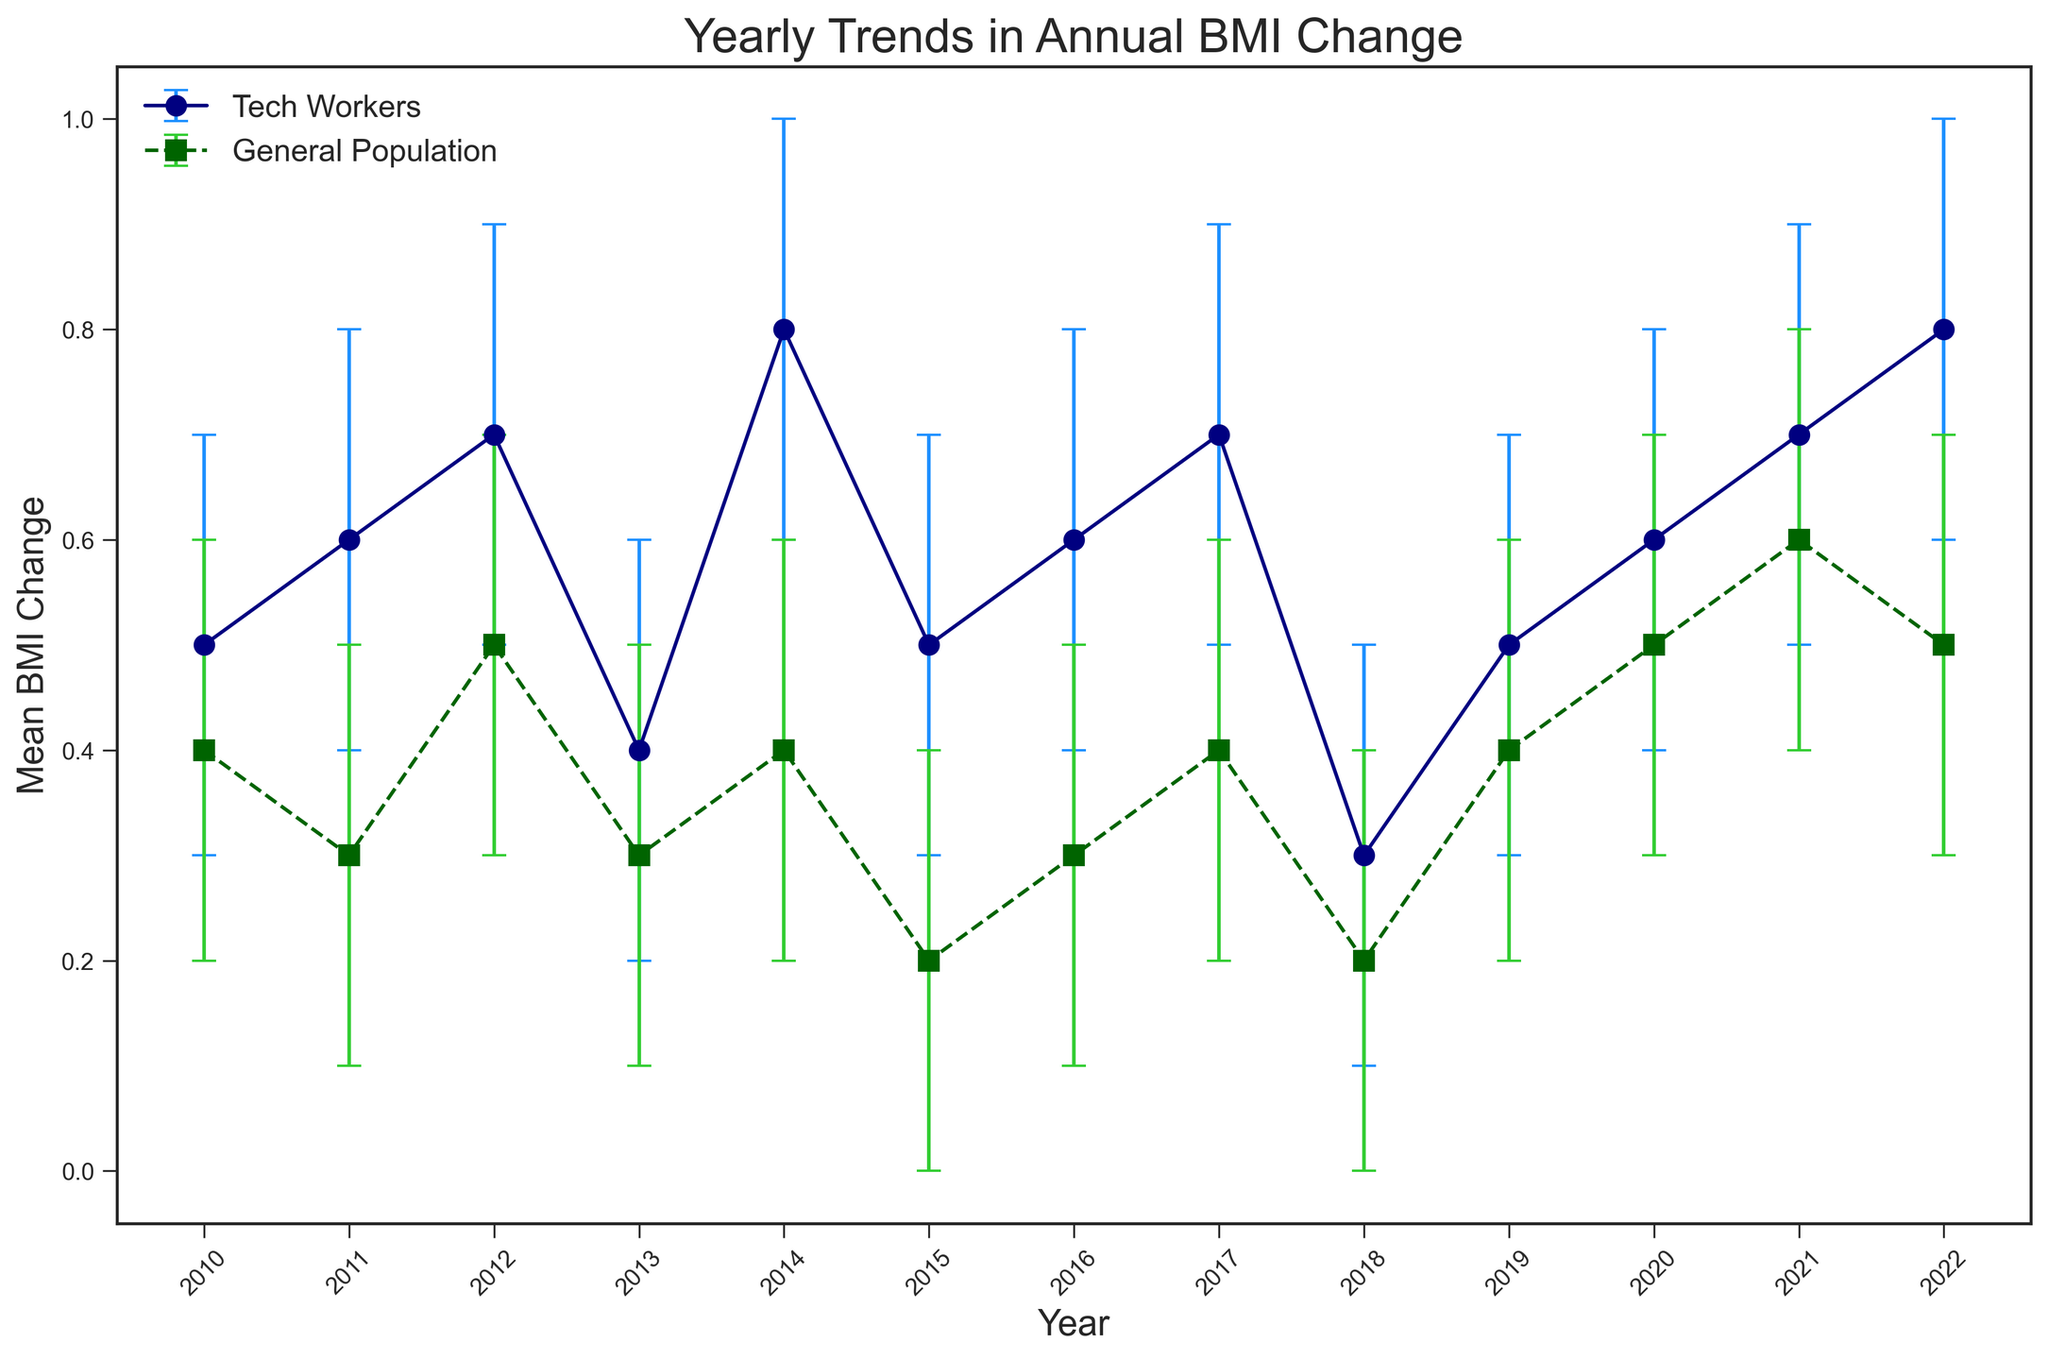What's the general trend of BMI changes for Tech Workers from 2010 to 2022? By examining the figure, we can observe that the Mean BMI Change for Tech Workers generally increases over the years, with some fluctuations.
Answer: Increasing In which year did the Tech Workers experience their highest mean BMI change? By comparing the mean BMI changes of Tech Workers for each year, the highest data point is in 2022 with a mean BMI change of 0.8.
Answer: 2022 How does the trend in the general population compare to the trend in Tech Workers over the years? By inspecting the plot, we can see that the BMI changes in the general population remain relatively stable compared to Tech Workers, which show more variability and a generally increasing trend.
Answer: More stable In which years did the Tech Workers have a higher mean BMI change than the General Population? By observing the plotted data points, Tech Workers had higher mean BMI changes than the General Population in 2010, 2011, 2012, 2014, 2015, 2016, 2017, 2020, 2021, and 2022.
Answer: 2010, 2011, 2012, 2014, 2015, 2016, 2017, 2020, 2021, 2022 Which population had the lowest mean BMI change in the year 2015? By checking the figure, the General Population had a mean BMI change of 0.2 in 2015, compared to the Tech Workers' 0.5 in the same year.
Answer: General Population What is the difference in mean BMI change between Tech Workers and the General Population in 2014? The mean BMI change for Tech Workers in 2014 is 0.8 and for the General Population is 0.4. The difference is 0.8 - 0.4 = 0.4.
Answer: 0.4 In which year did both populations experience the same mean BMI change? By scanning the data for each year, there was no year in which both Tech Workers and the General Population had the same mean BMI change.
Answer: None What is the average mean BMI change for Tech Workers over the entire period? Summing up the mean BMI changes for Tech Workers from 2010 to 2022 and dividing by the number of years (0.5 + 0.6 + 0.7 + 0.4 + 0.8 + 0.5 + 0.6 + 0.7 + 0.3 + 0.5 + 0.6 + 0.7 + 0.8) / 13, we get the average. (7.7 / 13)
Answer: 0.592 Which population experienced more variability in mean BMI changes over the years? By analyzing the fluctuations in the plotted data, Tech Workers clearly show more variability in their mean BMI changes compared to the General Population.
Answer: Tech Workers What is the confidence interval range for General Population in 2020? The lower confidence interval for General Population in 2020 is 0.3, and the upper confidence interval is 0.7. The range is 0.7 - 0.3.
Answer: 0.4 